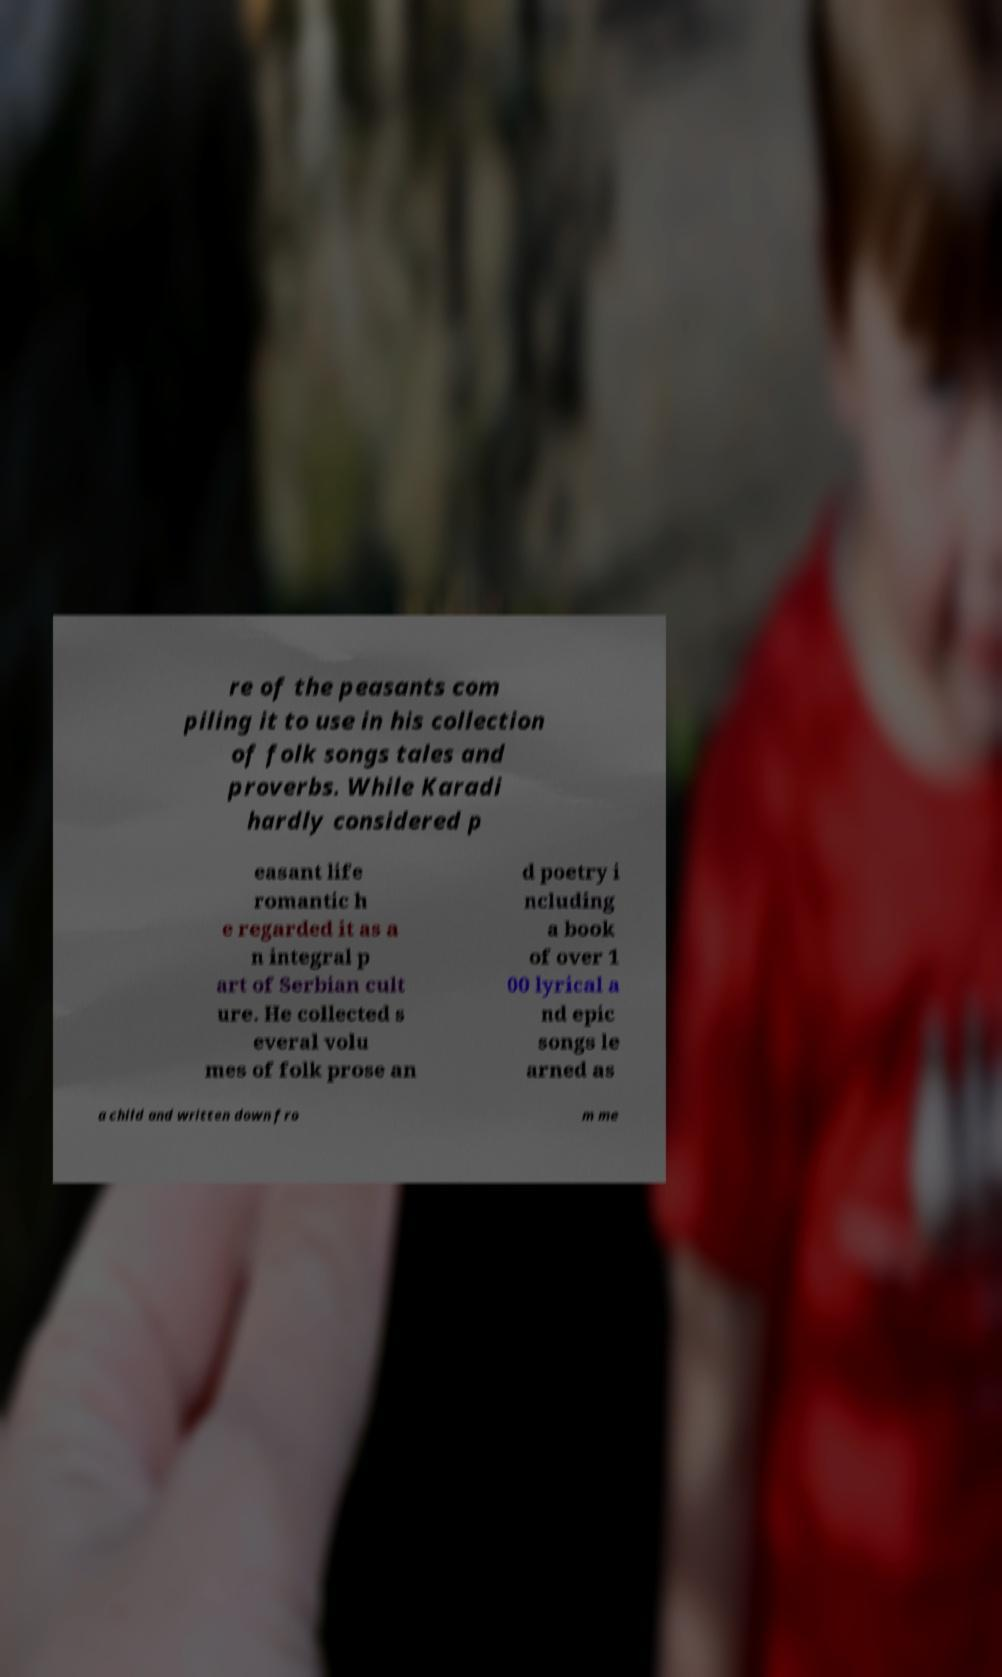Can you accurately transcribe the text from the provided image for me? re of the peasants com piling it to use in his collection of folk songs tales and proverbs. While Karadi hardly considered p easant life romantic h e regarded it as a n integral p art of Serbian cult ure. He collected s everal volu mes of folk prose an d poetry i ncluding a book of over 1 00 lyrical a nd epic songs le arned as a child and written down fro m me 